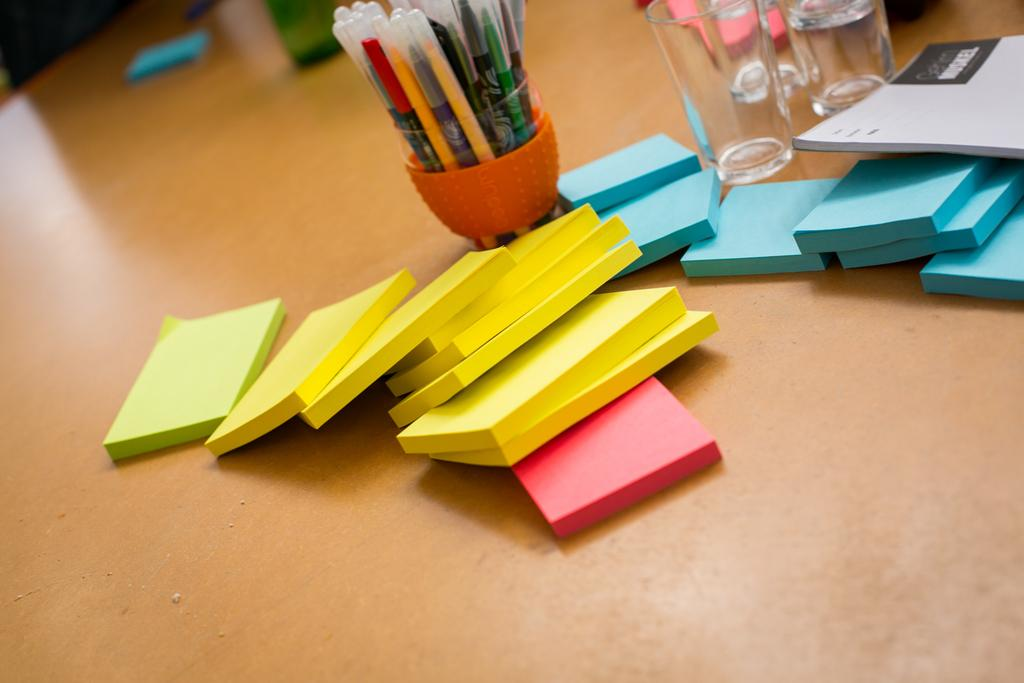What type of stationery items are visible in the image? There are self stick notepads, glasses, and a pen stand with pens in the image. Can you describe the pen stand in the image? The pen stand in the image has pens in it. What else can be seen on the table in the image? There are other unspecified items on the table in the image. What type of laborer is depicted working on the stomach in the image? There is no laborer or stomach present in the image; it features stationery items on a table. 